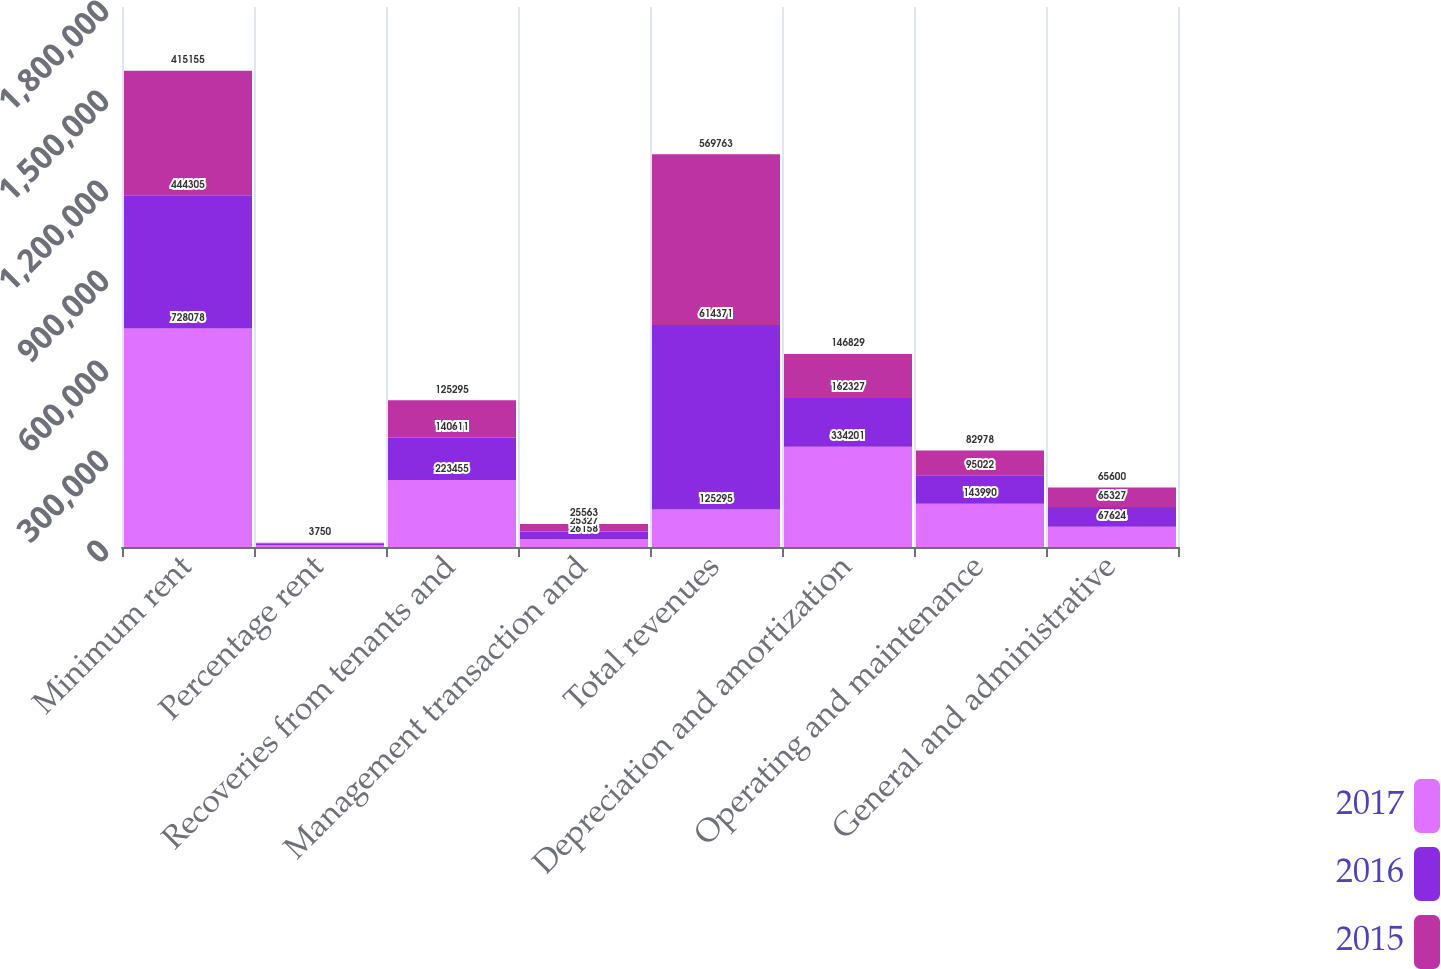Convert chart to OTSL. <chart><loc_0><loc_0><loc_500><loc_500><stacked_bar_chart><ecel><fcel>Minimum rent<fcel>Percentage rent<fcel>Recoveries from tenants and<fcel>Management transaction and<fcel>Total revenues<fcel>Depreciation and amortization<fcel>Operating and maintenance<fcel>General and administrative<nl><fcel>2017<fcel>728078<fcel>6635<fcel>223455<fcel>26158<fcel>125295<fcel>334201<fcel>143990<fcel>67624<nl><fcel>2016<fcel>444305<fcel>4128<fcel>140611<fcel>25327<fcel>614371<fcel>162327<fcel>95022<fcel>65327<nl><fcel>2015<fcel>415155<fcel>3750<fcel>125295<fcel>25563<fcel>569763<fcel>146829<fcel>82978<fcel>65600<nl></chart> 